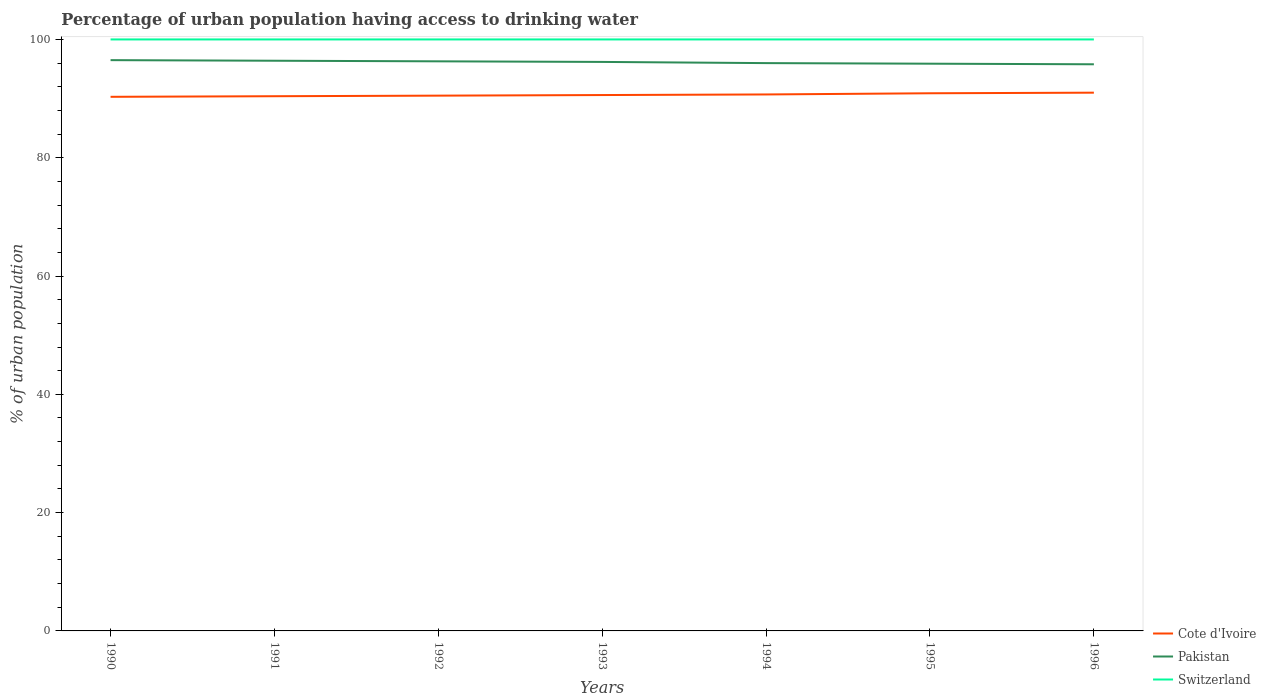How many different coloured lines are there?
Provide a short and direct response. 3. Does the line corresponding to Switzerland intersect with the line corresponding to Cote d'Ivoire?
Your answer should be very brief. No. Across all years, what is the maximum percentage of urban population having access to drinking water in Cote d'Ivoire?
Provide a short and direct response. 90.3. What is the total percentage of urban population having access to drinking water in Pakistan in the graph?
Ensure brevity in your answer.  0.1. What is the difference between the highest and the lowest percentage of urban population having access to drinking water in Pakistan?
Keep it short and to the point. 4. How many lines are there?
Keep it short and to the point. 3. Does the graph contain grids?
Keep it short and to the point. No. How are the legend labels stacked?
Your answer should be compact. Vertical. What is the title of the graph?
Give a very brief answer. Percentage of urban population having access to drinking water. What is the label or title of the X-axis?
Offer a terse response. Years. What is the label or title of the Y-axis?
Give a very brief answer. % of urban population. What is the % of urban population in Cote d'Ivoire in 1990?
Provide a succinct answer. 90.3. What is the % of urban population of Pakistan in 1990?
Offer a very short reply. 96.5. What is the % of urban population in Cote d'Ivoire in 1991?
Your response must be concise. 90.4. What is the % of urban population in Pakistan in 1991?
Offer a terse response. 96.4. What is the % of urban population in Switzerland in 1991?
Your response must be concise. 100. What is the % of urban population of Cote d'Ivoire in 1992?
Make the answer very short. 90.5. What is the % of urban population in Pakistan in 1992?
Your response must be concise. 96.3. What is the % of urban population in Cote d'Ivoire in 1993?
Offer a terse response. 90.6. What is the % of urban population in Pakistan in 1993?
Your response must be concise. 96.2. What is the % of urban population of Cote d'Ivoire in 1994?
Offer a terse response. 90.7. What is the % of urban population in Pakistan in 1994?
Offer a terse response. 96. What is the % of urban population of Switzerland in 1994?
Your answer should be compact. 100. What is the % of urban population in Cote d'Ivoire in 1995?
Your response must be concise. 90.9. What is the % of urban population in Pakistan in 1995?
Your answer should be very brief. 95.9. What is the % of urban population of Cote d'Ivoire in 1996?
Offer a terse response. 91. What is the % of urban population of Pakistan in 1996?
Keep it short and to the point. 95.8. What is the % of urban population in Switzerland in 1996?
Offer a terse response. 100. Across all years, what is the maximum % of urban population in Cote d'Ivoire?
Make the answer very short. 91. Across all years, what is the maximum % of urban population of Pakistan?
Your response must be concise. 96.5. Across all years, what is the minimum % of urban population of Cote d'Ivoire?
Give a very brief answer. 90.3. Across all years, what is the minimum % of urban population in Pakistan?
Offer a very short reply. 95.8. Across all years, what is the minimum % of urban population in Switzerland?
Give a very brief answer. 100. What is the total % of urban population of Cote d'Ivoire in the graph?
Provide a short and direct response. 634.4. What is the total % of urban population of Pakistan in the graph?
Your answer should be very brief. 673.1. What is the total % of urban population in Switzerland in the graph?
Make the answer very short. 700. What is the difference between the % of urban population in Cote d'Ivoire in 1990 and that in 1991?
Provide a short and direct response. -0.1. What is the difference between the % of urban population in Switzerland in 1990 and that in 1991?
Your response must be concise. 0. What is the difference between the % of urban population of Switzerland in 1990 and that in 1992?
Your answer should be very brief. 0. What is the difference between the % of urban population in Pakistan in 1990 and that in 1993?
Your answer should be very brief. 0.3. What is the difference between the % of urban population in Switzerland in 1990 and that in 1993?
Offer a terse response. 0. What is the difference between the % of urban population of Cote d'Ivoire in 1990 and that in 1994?
Your answer should be very brief. -0.4. What is the difference between the % of urban population of Cote d'Ivoire in 1990 and that in 1995?
Offer a very short reply. -0.6. What is the difference between the % of urban population in Pakistan in 1990 and that in 1995?
Your answer should be very brief. 0.6. What is the difference between the % of urban population of Switzerland in 1990 and that in 1995?
Offer a very short reply. 0. What is the difference between the % of urban population in Pakistan in 1990 and that in 1996?
Provide a succinct answer. 0.7. What is the difference between the % of urban population of Cote d'Ivoire in 1991 and that in 1992?
Offer a very short reply. -0.1. What is the difference between the % of urban population in Pakistan in 1991 and that in 1992?
Keep it short and to the point. 0.1. What is the difference between the % of urban population in Cote d'Ivoire in 1991 and that in 1993?
Provide a succinct answer. -0.2. What is the difference between the % of urban population of Pakistan in 1991 and that in 1993?
Provide a succinct answer. 0.2. What is the difference between the % of urban population in Cote d'Ivoire in 1991 and that in 1994?
Ensure brevity in your answer.  -0.3. What is the difference between the % of urban population of Pakistan in 1991 and that in 1994?
Offer a terse response. 0.4. What is the difference between the % of urban population in Switzerland in 1991 and that in 1995?
Offer a very short reply. 0. What is the difference between the % of urban population of Cote d'Ivoire in 1991 and that in 1996?
Offer a terse response. -0.6. What is the difference between the % of urban population in Pakistan in 1991 and that in 1996?
Your answer should be compact. 0.6. What is the difference between the % of urban population of Pakistan in 1992 and that in 1993?
Offer a very short reply. 0.1. What is the difference between the % of urban population of Switzerland in 1992 and that in 1994?
Ensure brevity in your answer.  0. What is the difference between the % of urban population in Cote d'Ivoire in 1992 and that in 1995?
Offer a terse response. -0.4. What is the difference between the % of urban population in Pakistan in 1992 and that in 1995?
Ensure brevity in your answer.  0.4. What is the difference between the % of urban population of Switzerland in 1992 and that in 1995?
Your answer should be very brief. 0. What is the difference between the % of urban population of Cote d'Ivoire in 1992 and that in 1996?
Your answer should be very brief. -0.5. What is the difference between the % of urban population in Pakistan in 1992 and that in 1996?
Give a very brief answer. 0.5. What is the difference between the % of urban population of Switzerland in 1992 and that in 1996?
Offer a terse response. 0. What is the difference between the % of urban population of Cote d'Ivoire in 1993 and that in 1994?
Give a very brief answer. -0.1. What is the difference between the % of urban population in Cote d'Ivoire in 1993 and that in 1995?
Provide a succinct answer. -0.3. What is the difference between the % of urban population of Pakistan in 1993 and that in 1995?
Your answer should be compact. 0.3. What is the difference between the % of urban population in Switzerland in 1993 and that in 1995?
Offer a terse response. 0. What is the difference between the % of urban population of Cote d'Ivoire in 1994 and that in 1995?
Offer a terse response. -0.2. What is the difference between the % of urban population in Pakistan in 1994 and that in 1996?
Ensure brevity in your answer.  0.2. What is the difference between the % of urban population of Switzerland in 1994 and that in 1996?
Your response must be concise. 0. What is the difference between the % of urban population of Cote d'Ivoire in 1995 and that in 1996?
Provide a short and direct response. -0.1. What is the difference between the % of urban population in Switzerland in 1995 and that in 1996?
Your answer should be very brief. 0. What is the difference between the % of urban population in Pakistan in 1990 and the % of urban population in Switzerland in 1991?
Your response must be concise. -3.5. What is the difference between the % of urban population of Pakistan in 1990 and the % of urban population of Switzerland in 1992?
Provide a short and direct response. -3.5. What is the difference between the % of urban population in Cote d'Ivoire in 1990 and the % of urban population in Pakistan in 1993?
Keep it short and to the point. -5.9. What is the difference between the % of urban population in Pakistan in 1990 and the % of urban population in Switzerland in 1993?
Your answer should be very brief. -3.5. What is the difference between the % of urban population in Cote d'Ivoire in 1990 and the % of urban population in Pakistan in 1994?
Ensure brevity in your answer.  -5.7. What is the difference between the % of urban population in Cote d'Ivoire in 1990 and the % of urban population in Switzerland in 1995?
Provide a succinct answer. -9.7. What is the difference between the % of urban population in Cote d'Ivoire in 1990 and the % of urban population in Pakistan in 1996?
Make the answer very short. -5.5. What is the difference between the % of urban population of Cote d'Ivoire in 1990 and the % of urban population of Switzerland in 1996?
Give a very brief answer. -9.7. What is the difference between the % of urban population in Pakistan in 1990 and the % of urban population in Switzerland in 1996?
Your answer should be compact. -3.5. What is the difference between the % of urban population of Cote d'Ivoire in 1991 and the % of urban population of Pakistan in 1992?
Provide a short and direct response. -5.9. What is the difference between the % of urban population of Cote d'Ivoire in 1991 and the % of urban population of Switzerland in 1992?
Your response must be concise. -9.6. What is the difference between the % of urban population in Pakistan in 1991 and the % of urban population in Switzerland in 1993?
Your response must be concise. -3.6. What is the difference between the % of urban population in Pakistan in 1991 and the % of urban population in Switzerland in 1995?
Give a very brief answer. -3.6. What is the difference between the % of urban population of Cote d'Ivoire in 1991 and the % of urban population of Switzerland in 1996?
Your response must be concise. -9.6. What is the difference between the % of urban population in Cote d'Ivoire in 1992 and the % of urban population in Pakistan in 1993?
Provide a short and direct response. -5.7. What is the difference between the % of urban population in Cote d'Ivoire in 1992 and the % of urban population in Switzerland in 1993?
Give a very brief answer. -9.5. What is the difference between the % of urban population in Pakistan in 1992 and the % of urban population in Switzerland in 1994?
Make the answer very short. -3.7. What is the difference between the % of urban population of Cote d'Ivoire in 1992 and the % of urban population of Pakistan in 1995?
Make the answer very short. -5.4. What is the difference between the % of urban population in Cote d'Ivoire in 1992 and the % of urban population in Switzerland in 1995?
Offer a terse response. -9.5. What is the difference between the % of urban population in Pakistan in 1992 and the % of urban population in Switzerland in 1995?
Offer a terse response. -3.7. What is the difference between the % of urban population in Cote d'Ivoire in 1992 and the % of urban population in Switzerland in 1996?
Your response must be concise. -9.5. What is the difference between the % of urban population in Cote d'Ivoire in 1993 and the % of urban population in Switzerland in 1994?
Keep it short and to the point. -9.4. What is the difference between the % of urban population of Pakistan in 1993 and the % of urban population of Switzerland in 1994?
Keep it short and to the point. -3.8. What is the difference between the % of urban population of Cote d'Ivoire in 1993 and the % of urban population of Pakistan in 1995?
Your response must be concise. -5.3. What is the difference between the % of urban population in Cote d'Ivoire in 1993 and the % of urban population in Switzerland in 1995?
Keep it short and to the point. -9.4. What is the difference between the % of urban population of Cote d'Ivoire in 1993 and the % of urban population of Switzerland in 1996?
Your answer should be very brief. -9.4. What is the difference between the % of urban population of Cote d'Ivoire in 1994 and the % of urban population of Pakistan in 1995?
Keep it short and to the point. -5.2. What is the difference between the % of urban population of Cote d'Ivoire in 1994 and the % of urban population of Switzerland in 1995?
Your answer should be very brief. -9.3. What is the difference between the % of urban population of Pakistan in 1994 and the % of urban population of Switzerland in 1995?
Your answer should be compact. -4. What is the difference between the % of urban population of Cote d'Ivoire in 1995 and the % of urban population of Pakistan in 1996?
Offer a very short reply. -4.9. What is the difference between the % of urban population of Cote d'Ivoire in 1995 and the % of urban population of Switzerland in 1996?
Your response must be concise. -9.1. What is the average % of urban population in Cote d'Ivoire per year?
Your answer should be very brief. 90.63. What is the average % of urban population of Pakistan per year?
Your answer should be compact. 96.16. In the year 1990, what is the difference between the % of urban population in Cote d'Ivoire and % of urban population in Switzerland?
Ensure brevity in your answer.  -9.7. In the year 1990, what is the difference between the % of urban population in Pakistan and % of urban population in Switzerland?
Ensure brevity in your answer.  -3.5. In the year 1991, what is the difference between the % of urban population of Pakistan and % of urban population of Switzerland?
Make the answer very short. -3.6. In the year 1992, what is the difference between the % of urban population in Pakistan and % of urban population in Switzerland?
Provide a short and direct response. -3.7. In the year 1993, what is the difference between the % of urban population in Cote d'Ivoire and % of urban population in Switzerland?
Offer a terse response. -9.4. In the year 1993, what is the difference between the % of urban population in Pakistan and % of urban population in Switzerland?
Offer a terse response. -3.8. In the year 1994, what is the difference between the % of urban population of Cote d'Ivoire and % of urban population of Pakistan?
Your answer should be compact. -5.3. In the year 1994, what is the difference between the % of urban population in Cote d'Ivoire and % of urban population in Switzerland?
Your answer should be very brief. -9.3. In the year 1995, what is the difference between the % of urban population of Pakistan and % of urban population of Switzerland?
Your answer should be very brief. -4.1. In the year 1996, what is the difference between the % of urban population of Cote d'Ivoire and % of urban population of Pakistan?
Offer a terse response. -4.8. What is the ratio of the % of urban population in Pakistan in 1990 to that in 1991?
Ensure brevity in your answer.  1. What is the ratio of the % of urban population in Switzerland in 1990 to that in 1991?
Provide a succinct answer. 1. What is the ratio of the % of urban population of Cote d'Ivoire in 1990 to that in 1992?
Provide a succinct answer. 1. What is the ratio of the % of urban population of Pakistan in 1990 to that in 1992?
Provide a short and direct response. 1. What is the ratio of the % of urban population of Switzerland in 1990 to that in 1992?
Provide a succinct answer. 1. What is the ratio of the % of urban population in Cote d'Ivoire in 1990 to that in 1993?
Ensure brevity in your answer.  1. What is the ratio of the % of urban population of Cote d'Ivoire in 1990 to that in 1994?
Make the answer very short. 1. What is the ratio of the % of urban population in Pakistan in 1990 to that in 1994?
Provide a succinct answer. 1.01. What is the ratio of the % of urban population in Pakistan in 1990 to that in 1995?
Offer a very short reply. 1.01. What is the ratio of the % of urban population of Switzerland in 1990 to that in 1995?
Give a very brief answer. 1. What is the ratio of the % of urban population of Pakistan in 1990 to that in 1996?
Your answer should be very brief. 1.01. What is the ratio of the % of urban population in Switzerland in 1990 to that in 1996?
Provide a short and direct response. 1. What is the ratio of the % of urban population of Cote d'Ivoire in 1991 to that in 1992?
Make the answer very short. 1. What is the ratio of the % of urban population of Pakistan in 1991 to that in 1992?
Your answer should be very brief. 1. What is the ratio of the % of urban population of Switzerland in 1991 to that in 1992?
Your answer should be compact. 1. What is the ratio of the % of urban population in Cote d'Ivoire in 1991 to that in 1993?
Your answer should be compact. 1. What is the ratio of the % of urban population of Pakistan in 1991 to that in 1993?
Ensure brevity in your answer.  1. What is the ratio of the % of urban population in Cote d'Ivoire in 1991 to that in 1994?
Your answer should be very brief. 1. What is the ratio of the % of urban population of Cote d'Ivoire in 1991 to that in 1995?
Make the answer very short. 0.99. What is the ratio of the % of urban population of Switzerland in 1991 to that in 1995?
Provide a succinct answer. 1. What is the ratio of the % of urban population of Switzerland in 1991 to that in 1996?
Keep it short and to the point. 1. What is the ratio of the % of urban population of Cote d'Ivoire in 1992 to that in 1993?
Your answer should be compact. 1. What is the ratio of the % of urban population in Switzerland in 1992 to that in 1993?
Make the answer very short. 1. What is the ratio of the % of urban population in Cote d'Ivoire in 1992 to that in 1994?
Make the answer very short. 1. What is the ratio of the % of urban population in Pakistan in 1992 to that in 1994?
Your response must be concise. 1. What is the ratio of the % of urban population of Switzerland in 1992 to that in 1994?
Make the answer very short. 1. What is the ratio of the % of urban population in Pakistan in 1992 to that in 1995?
Make the answer very short. 1. What is the ratio of the % of urban population in Switzerland in 1992 to that in 1996?
Ensure brevity in your answer.  1. What is the ratio of the % of urban population in Pakistan in 1993 to that in 1994?
Keep it short and to the point. 1. What is the ratio of the % of urban population in Switzerland in 1993 to that in 1994?
Your response must be concise. 1. What is the ratio of the % of urban population in Cote d'Ivoire in 1993 to that in 1995?
Your response must be concise. 1. What is the ratio of the % of urban population in Pakistan in 1993 to that in 1995?
Your answer should be very brief. 1. What is the ratio of the % of urban population in Switzerland in 1993 to that in 1995?
Your answer should be very brief. 1. What is the ratio of the % of urban population of Cote d'Ivoire in 1993 to that in 1996?
Keep it short and to the point. 1. What is the ratio of the % of urban population of Pakistan in 1993 to that in 1996?
Ensure brevity in your answer.  1. What is the ratio of the % of urban population of Switzerland in 1993 to that in 1996?
Provide a short and direct response. 1. What is the ratio of the % of urban population in Pakistan in 1994 to that in 1995?
Ensure brevity in your answer.  1. What is the ratio of the % of urban population of Pakistan in 1994 to that in 1996?
Ensure brevity in your answer.  1. What is the ratio of the % of urban population of Switzerland in 1994 to that in 1996?
Offer a terse response. 1. What is the ratio of the % of urban population in Cote d'Ivoire in 1995 to that in 1996?
Give a very brief answer. 1. What is the ratio of the % of urban population of Pakistan in 1995 to that in 1996?
Provide a succinct answer. 1. What is the difference between the highest and the second highest % of urban population of Cote d'Ivoire?
Offer a very short reply. 0.1. 